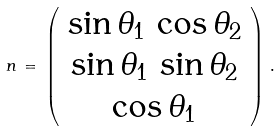Convert formula to latex. <formula><loc_0><loc_0><loc_500><loc_500>n \, = \, \left ( \begin{array} { c } \sin \theta _ { 1 } \, \cos \theta _ { 2 } \\ \sin \theta _ { 1 } \, \sin \theta _ { 2 } \\ \cos \theta _ { 1 } \end{array} \right ) \, .</formula> 